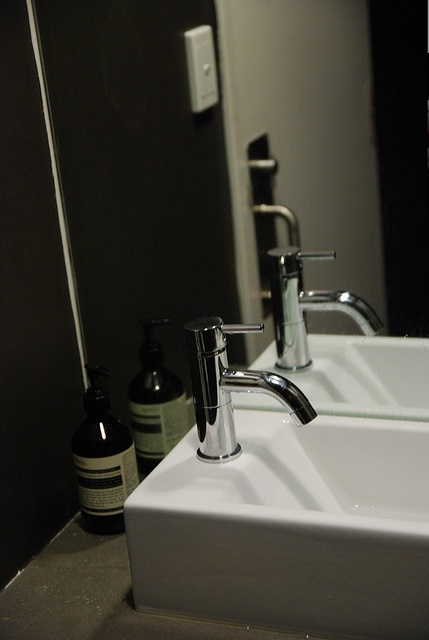Describe the objects in this image and their specific colors. I can see sink in black, darkgray, and lightgray tones, bottle in black, darkgreen, gray, and lightgray tones, sink in black, darkgray, and lightgray tones, and bottle in black, darkgreen, and gray tones in this image. 